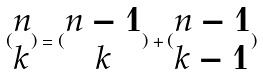Convert formula to latex. <formula><loc_0><loc_0><loc_500><loc_500>( \begin{matrix} n \\ k \end{matrix} ) = ( \begin{matrix} n - 1 \\ k \end{matrix} ) + ( \begin{matrix} n - 1 \\ k - 1 \end{matrix} )</formula> 